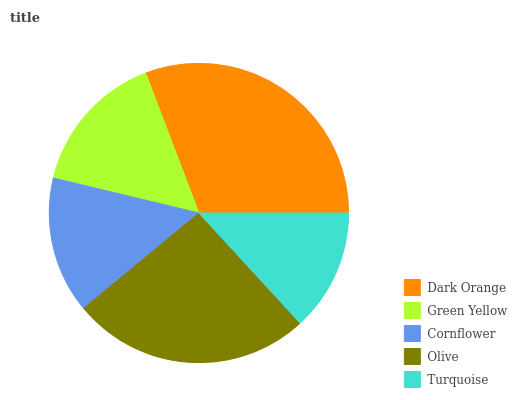Is Turquoise the minimum?
Answer yes or no. Yes. Is Dark Orange the maximum?
Answer yes or no. Yes. Is Green Yellow the minimum?
Answer yes or no. No. Is Green Yellow the maximum?
Answer yes or no. No. Is Dark Orange greater than Green Yellow?
Answer yes or no. Yes. Is Green Yellow less than Dark Orange?
Answer yes or no. Yes. Is Green Yellow greater than Dark Orange?
Answer yes or no. No. Is Dark Orange less than Green Yellow?
Answer yes or no. No. Is Green Yellow the high median?
Answer yes or no. Yes. Is Green Yellow the low median?
Answer yes or no. Yes. Is Cornflower the high median?
Answer yes or no. No. Is Turquoise the low median?
Answer yes or no. No. 